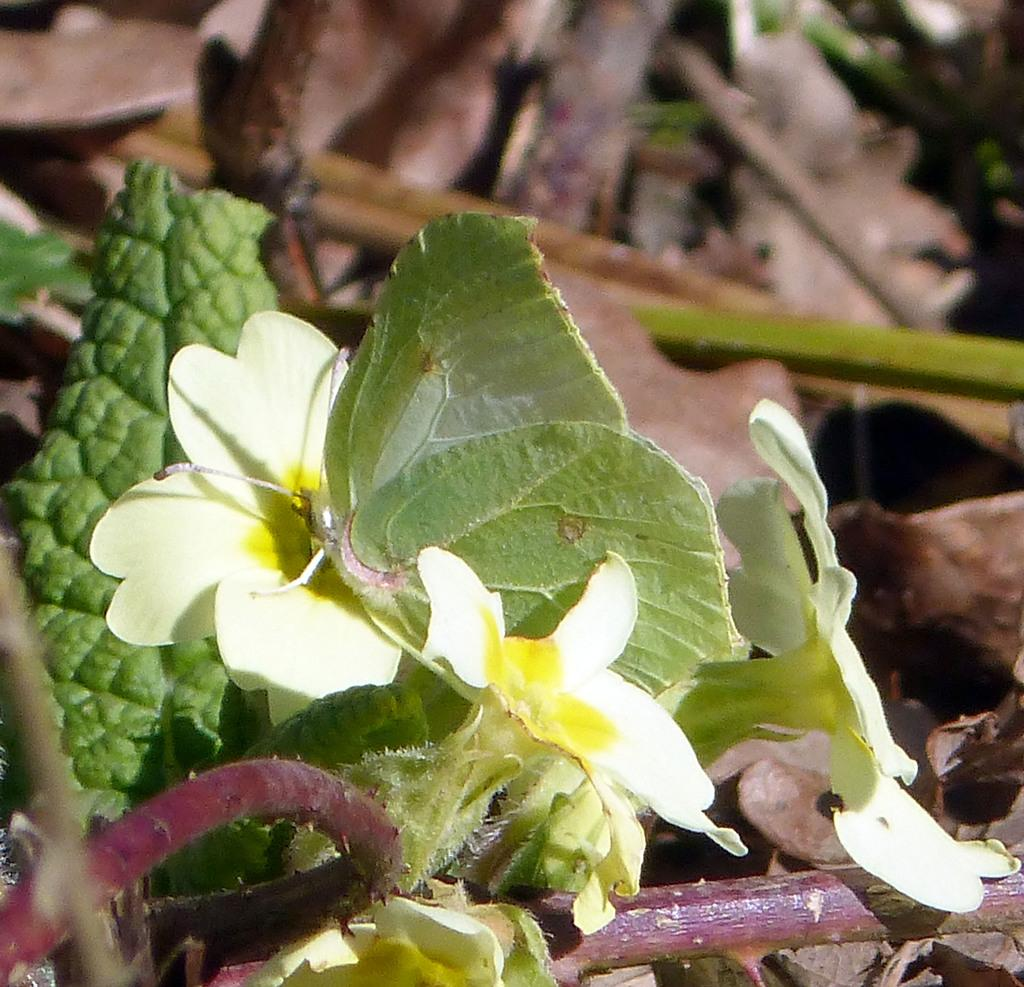What type of vegetation can be seen in the image? There are leaves in the image. What color are the leaves? The leaves are green in color. Can you describe the background of the image? The background of the image is blurred. What type of noise can be heard coming from the leaves in the image? There is no sound present in the image, as it is a still photograph. 